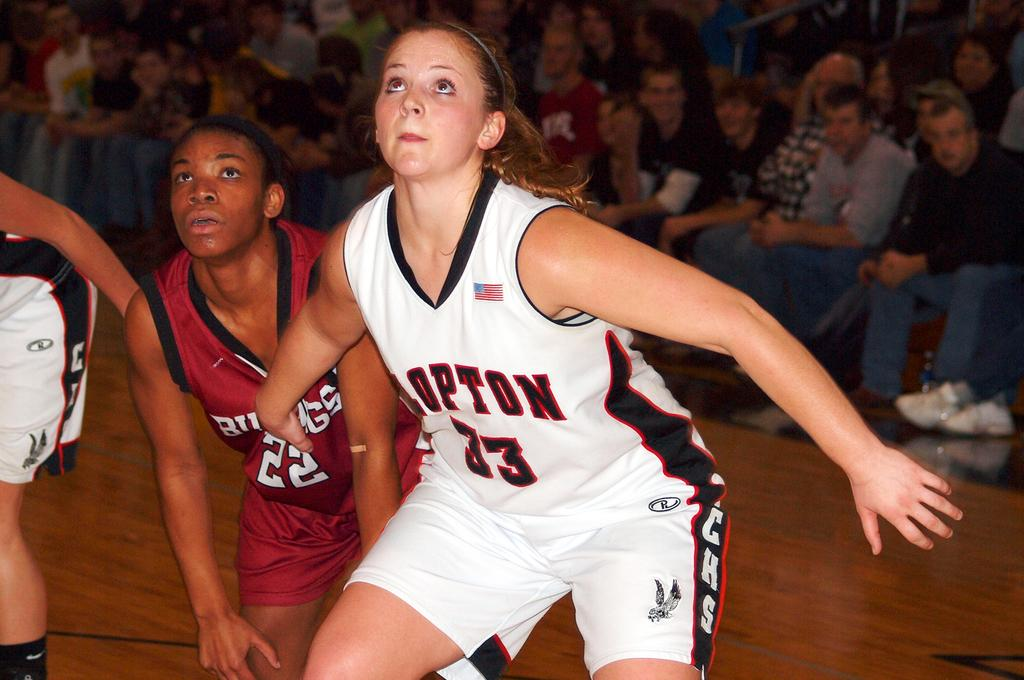<image>
Present a compact description of the photo's key features. a jersey with the number 33 on it 